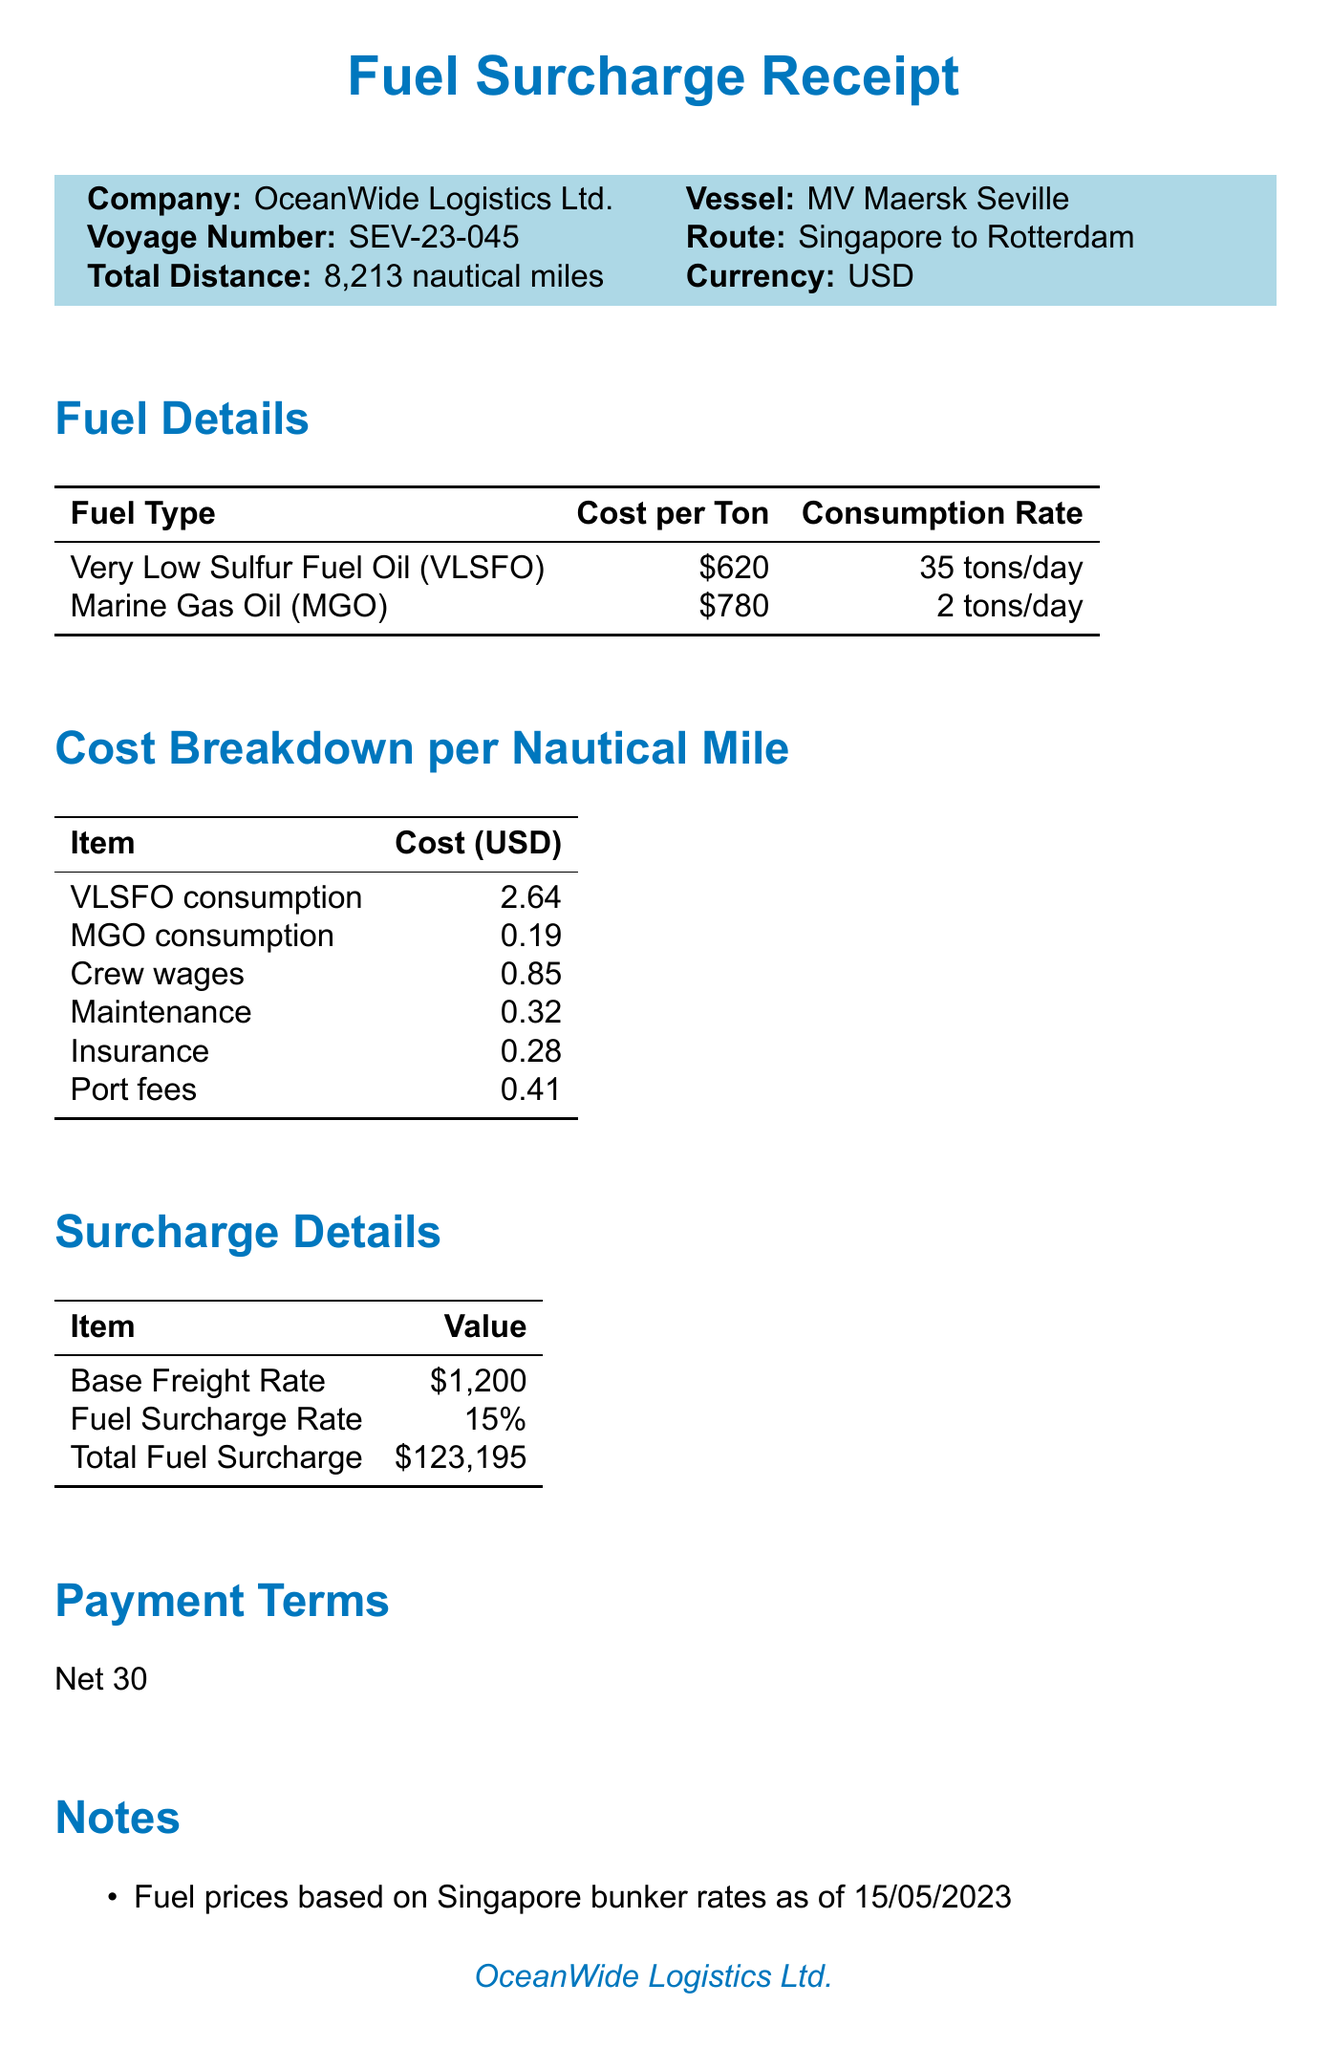What is the company name? The company name is presented prominently at the top of the document.
Answer: OceanWide Logistics Ltd What is the total distance of the voyage? The total distance is explicitly stated in the document.
Answer: 8,213 nautical miles What is the cost per ton of VLSFO? This specific information is detailed under the fuel details section.
Answer: 620 What is the fuel surcharge rate? The fuel surcharge rate is clearly listed in the surcharge details section.
Answer: 15% What are the potential savings from wind-assisted propulsion? The potential savings for this eco-friendly option is outlined in the options section.
Answer: 5-20% How much did crew wages contribute per nautical mile? The contribution of crew wages is specified in the cost breakdown section.
Answer: 0.85 What is the total fuel surcharge amount? The total fuel surcharge is clearly detailed in the surcharge details section.
Answer: 123,195 What are the payment terms? The payment terms are stated directly in the document.
Answer: Net 30 What type of fuel is used alongside VLSFO? The document lists fuel types very clearly in the fuel details section.
Answer: Marine Gas Oil (MGO) 